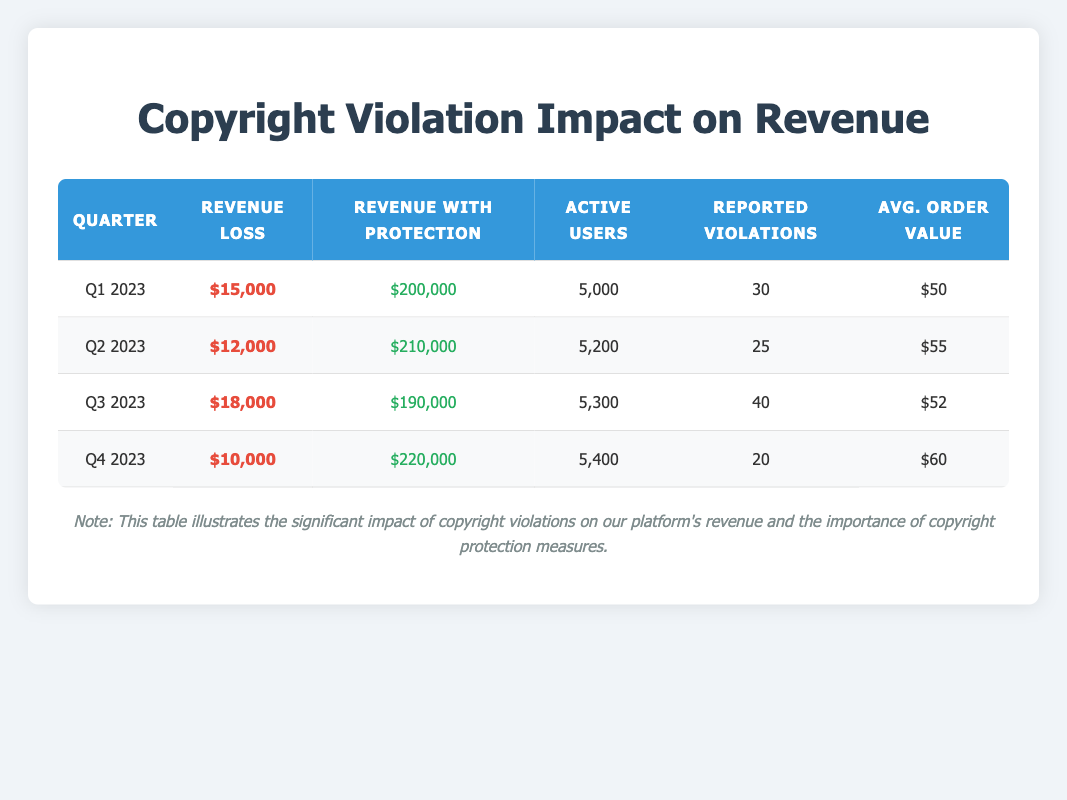What was the revenue loss in Q3 2023? According to the table, the revenue loss in Q3 2023 is specifically stated as $18,000.
Answer: $18,000 How many reported violations were there in Q2 2023? The table indicates that there were 25 reported violations in Q2 2023.
Answer: 25 What is the average revenue loss across all quarters? To find the average revenue loss, sum the revenue losses: (15,000 + 12,000 + 18,000 + 10,000) = 55,000. Then, divide by the number of quarters (4): 55,000 / 4 = 13,750.
Answer: 13,750 Did the average order value increase from Q1 to Q4 2023? The average order value in Q1 2023 was $50, and in Q4 2023 it was $60. Since $60 is greater than $50, the average order value did increase.
Answer: Yes What is the total revenue with protection for all quarters combined? To calculate the total revenue with protection, sum the revenue with protection for each quarter: (200,000 + 210,000 + 190,000 + 220,000) = 820,000.
Answer: 820,000 How many active users were there in Q4 2023 compared to Q1 2023? The table shows there were 5,000 active users in Q1 2023 and 5,400 in Q4 2023. Comparing these values, the active users increased from 5,000 to 5,400.
Answer: Increased What was the highest revenue loss recorded in a given quarter, and which quarter was it? The revenue losses recorded were: $15,000 in Q1, $12,000 in Q2, $18,000 in Q3, and $10,000 in Q4. The highest value is $18,000, which occurred in Q3 2023.
Answer: Q3 2023 Did the reported violations increase from Q2 to Q3 2023? In Q2 2023, the reported violations were 25, and in Q3 2023, they increased to 40. Since 40 is greater than 25, the reported violations did increase.
Answer: Yes What is the median average order value from the quarters listed? The average order values are $50, $55, $52, and $60. Arranging them from lowest to highest gives: $50, $52, $55, $60. The median of an even set is the average of the two middle numbers: (52 + 55) / 2 = 53.5.
Answer: 53.5 